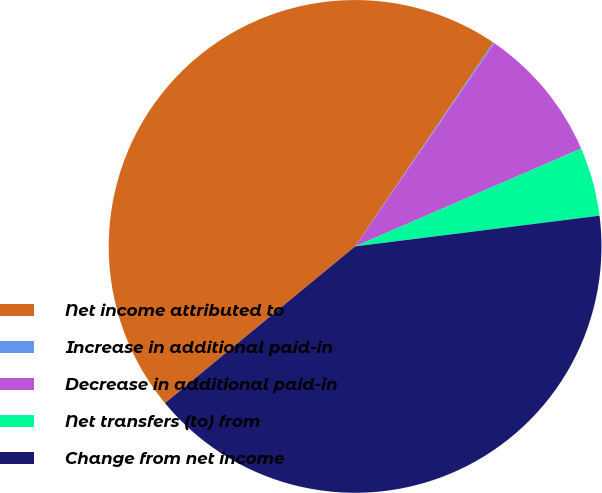<chart> <loc_0><loc_0><loc_500><loc_500><pie_chart><fcel>Net income attributed to<fcel>Increase in additional paid-in<fcel>Decrease in additional paid-in<fcel>Net transfers (to) from<fcel>Change from net income<nl><fcel>45.45%<fcel>0.08%<fcel>8.94%<fcel>4.51%<fcel>41.02%<nl></chart> 